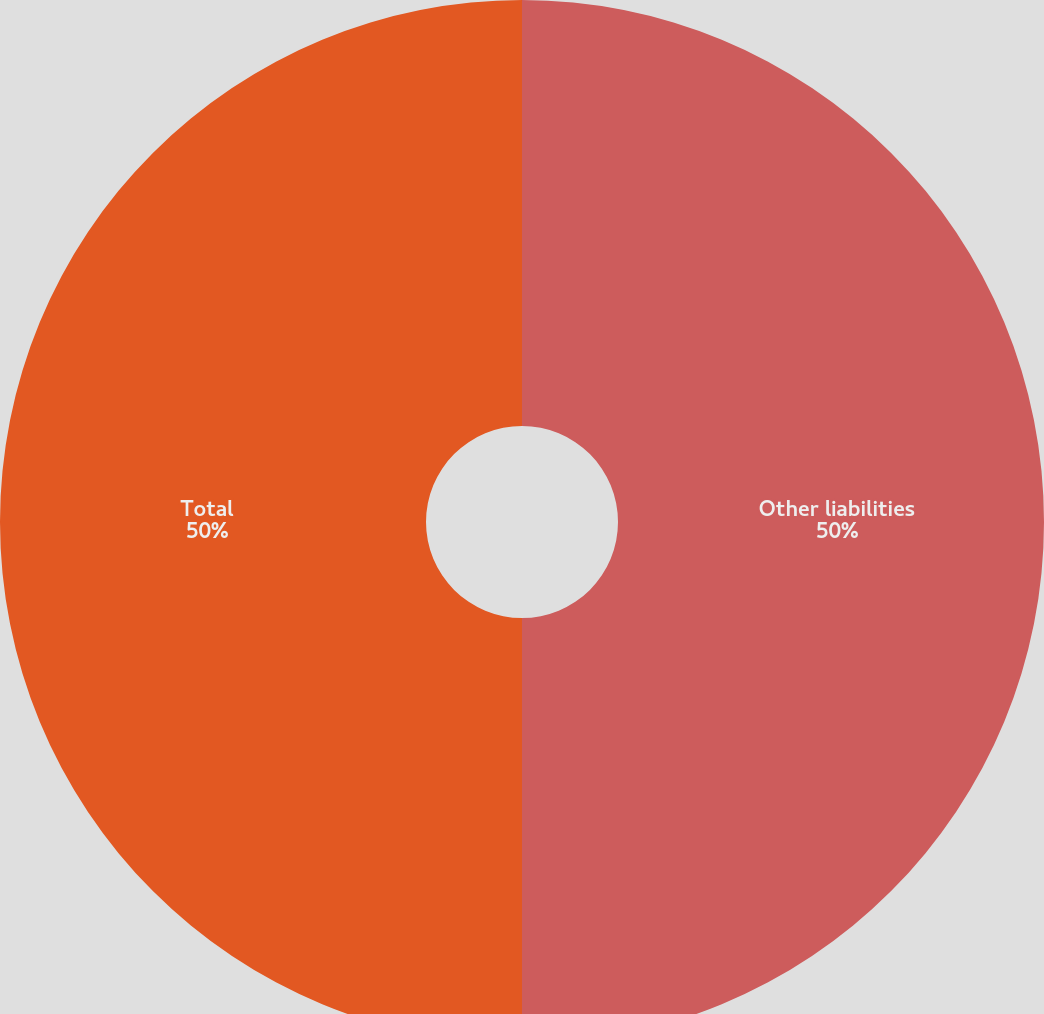<chart> <loc_0><loc_0><loc_500><loc_500><pie_chart><fcel>Other liabilities<fcel>Total<nl><fcel>50.0%<fcel>50.0%<nl></chart> 